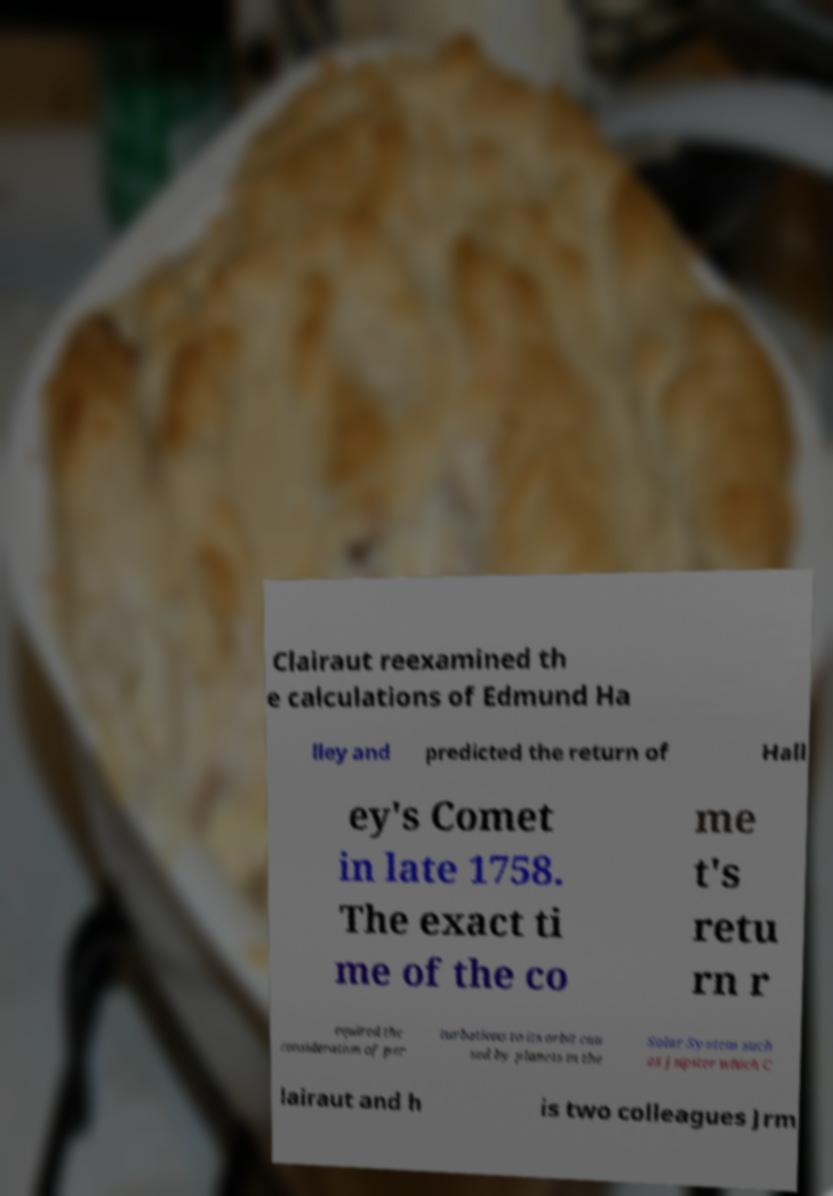Could you extract and type out the text from this image? Clairaut reexamined th e calculations of Edmund Ha lley and predicted the return of Hall ey's Comet in late 1758. The exact ti me of the co me t's retu rn r equired the consideration of per turbations to its orbit cau sed by planets in the Solar System such as Jupiter which C lairaut and h is two colleagues Jrm 